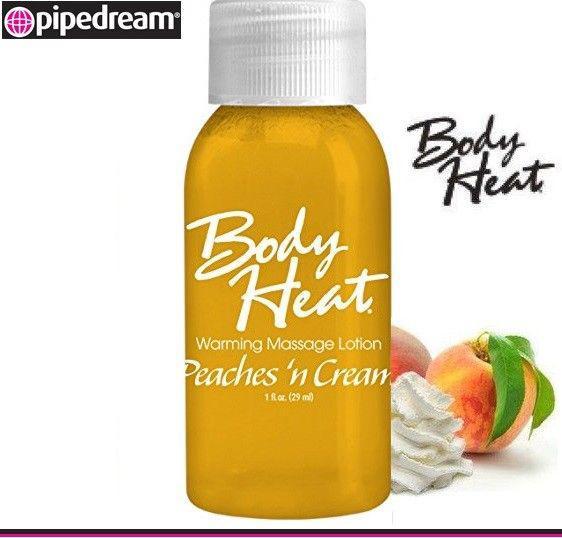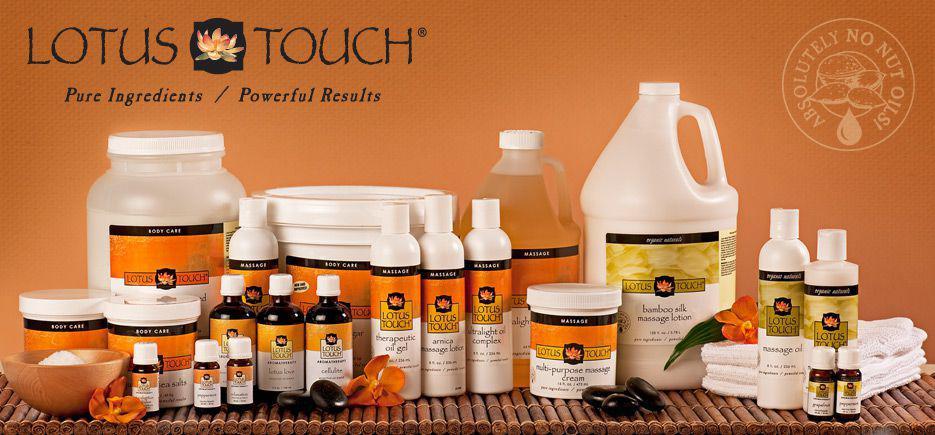The first image is the image on the left, the second image is the image on the right. Analyze the images presented: Is the assertion "Part of the human body is visible in one of the images." valid? Answer yes or no. No. The first image is the image on the left, the second image is the image on the right. Assess this claim about the two images: "There is a human body visible in one image.". Correct or not? Answer yes or no. No. 